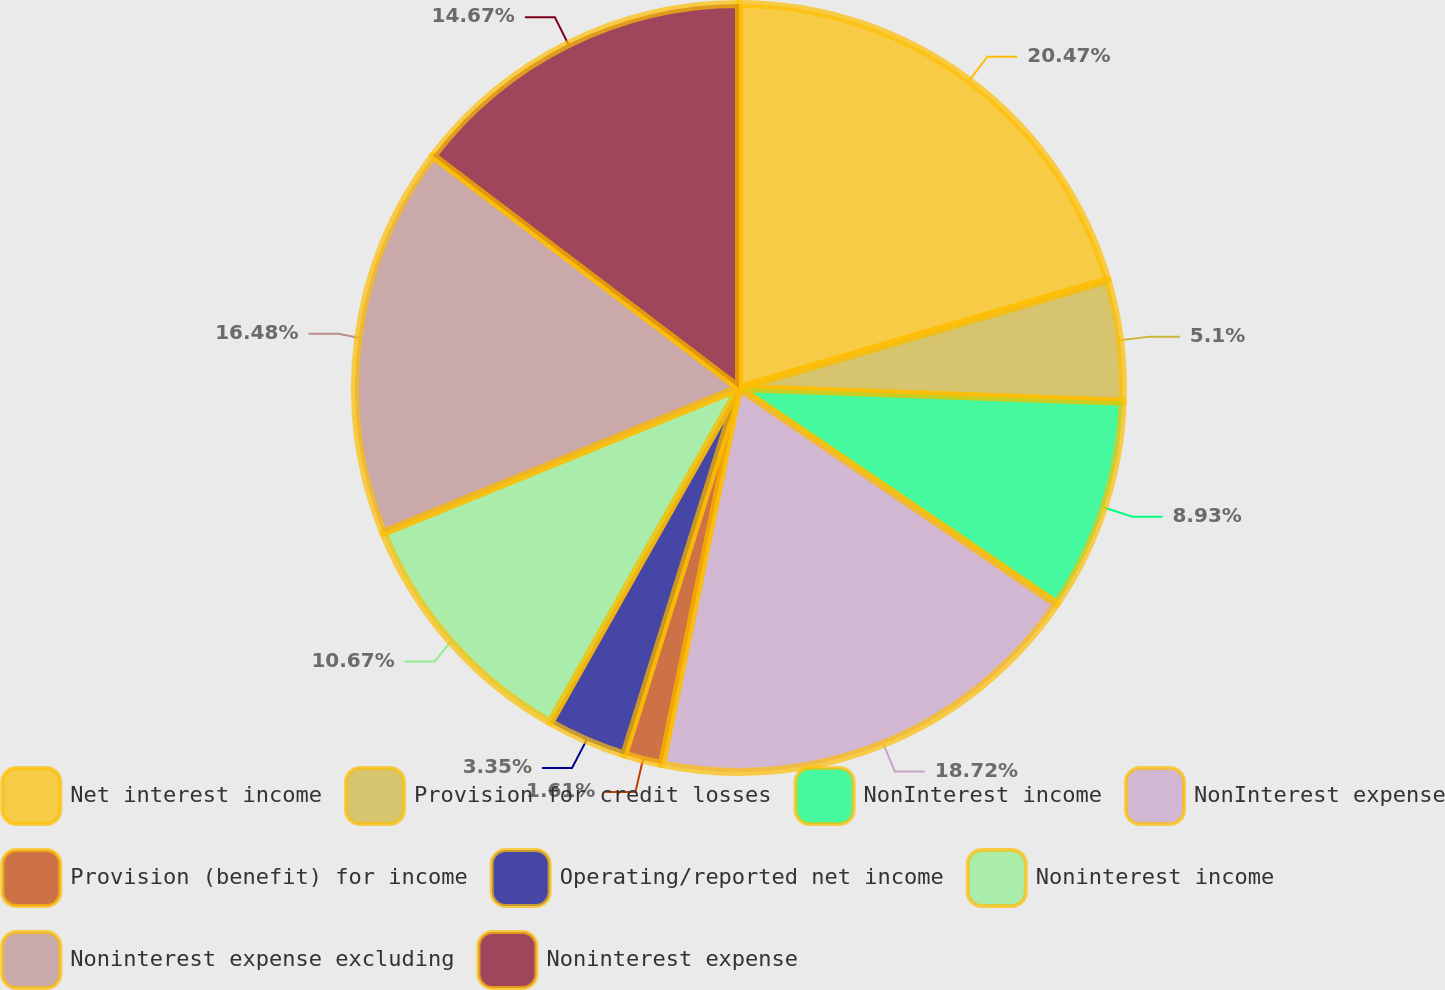Convert chart. <chart><loc_0><loc_0><loc_500><loc_500><pie_chart><fcel>Net interest income<fcel>Provision for credit losses<fcel>NonInterest income<fcel>NonInterest expense<fcel>Provision (benefit) for income<fcel>Operating/reported net income<fcel>Noninterest income<fcel>Noninterest expense excluding<fcel>Noninterest expense<nl><fcel>20.47%<fcel>5.1%<fcel>8.93%<fcel>18.72%<fcel>1.61%<fcel>3.35%<fcel>10.67%<fcel>16.48%<fcel>14.67%<nl></chart> 